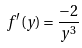<formula> <loc_0><loc_0><loc_500><loc_500>f ^ { \prime } ( y ) = \frac { - 2 } { y ^ { 3 } }</formula> 